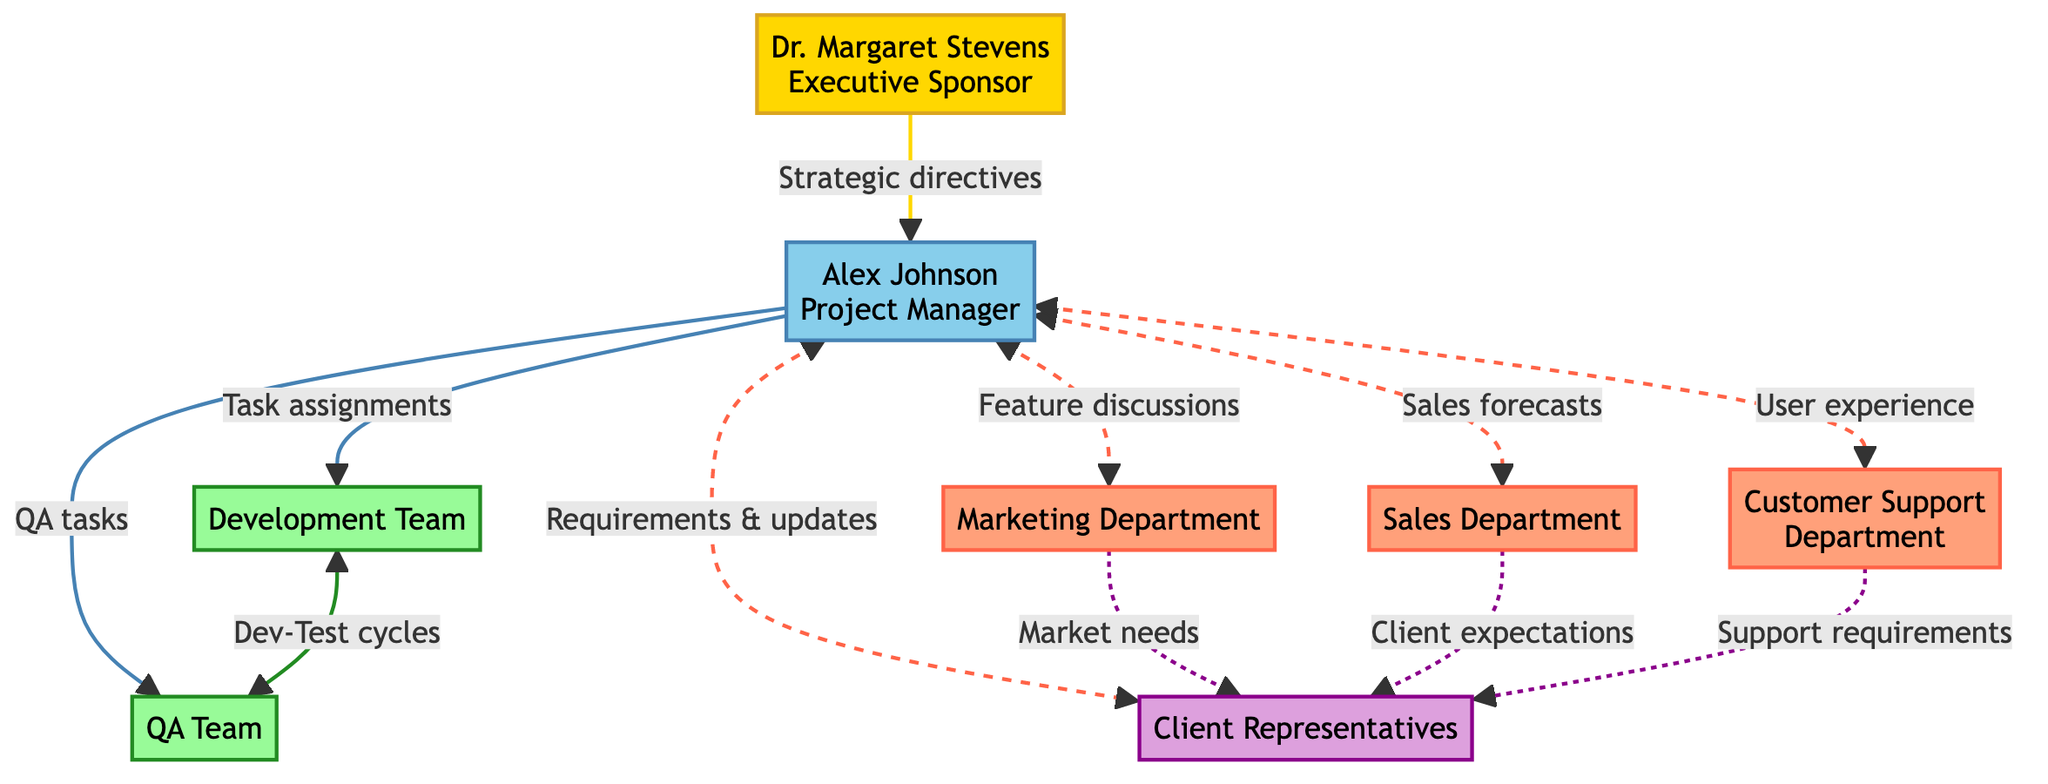What's the total number of nodes in the diagram? The nodes represent various stakeholders and team members involved in the project. By counting each unique entity listed under the nodes section, we find there are eight distinct nodes.
Answer: Eight Which type of relationship exists between the Project Manager and the Development Team? The edge between the Project Manager and the Development Team indicates a directive relationship, representing task assignments and progress reviews directed by the Project Manager.
Answer: Directive Who provides consultation to the Client Representatives related to market needs? By examining the connections leading to the Client Representatives, we see that the Marketing Department is specifically noted to provide consultation to ensure alignment on market needs and product acceptability.
Answer: Marketing Department How many feedback loops are present in the diagram? Feedback loops are described in the edges where communication is reciprocal. By counting the specified edges between the Project Manager and the Marketing, Sales, and Customer Support Departments, we find there are three feedback loops.
Answer: Three What is the main role of Dr. Margaret Stevens in the project? Dr. Margaret Stevens is identified as the Executive Sponsor in the diagram, which signifies she is responsible for providing strategic directives and oversight of overall project health monitoring.
Answer: Executive Sponsor Which team synchronizes on development and testing cycles? The connection between the Development Team and the QA Team labeled as collaboration indicates that these two teams work together on development and testing cycles.
Answer: QA Team What type of flow is indicated from the Sales Department to the Client Representatives? The flow between the Sales Department and the Client Representatives is a consultation relationship, indicating that the Sales Department provides input on client expectations and needs.
Answer: Consultation Identify the primary reporting structure from the Executive Sponsor. The edge from the Executive Sponsor to the Project Manager illustrates that the Executive Sponsor reports directly to the Project Manager, focusing on overall strategy and project health.
Answer: Project Manager What type of communication links the Project Manager to external stakeholders? The edges between the Project Manager and the Client Representatives are labeled as communication, indicating this type of relationship involves sharing updates and clarifying requirements with external stakeholders.
Answer: Communication 